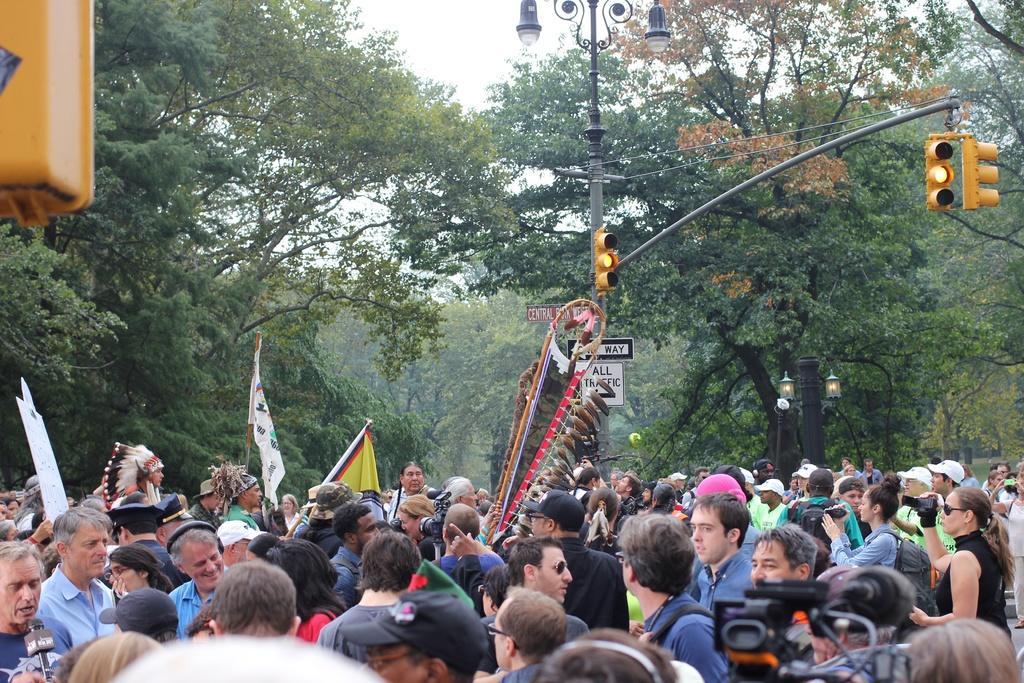Please provide a concise description of this image. In the center of the image we can see a few people are standing and they are in different costumes. Among them, we can see a few people are wearing backpacks, one person is smiling and a few people are holding some objects. At the top left side of the image, we can see a yellow color object. In the background, we can see the sky, trees, poles, sign boards, and traffic lights. 